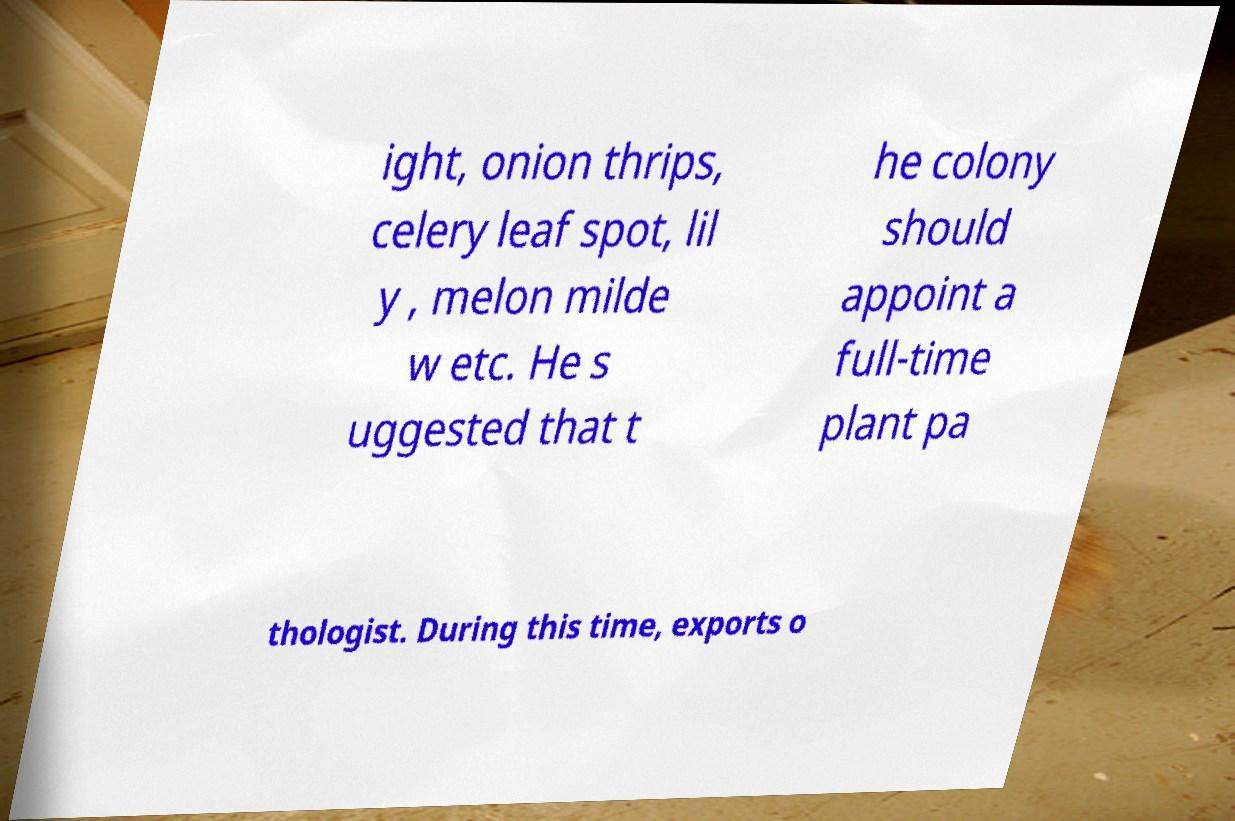Could you extract and type out the text from this image? ight, onion thrips, celery leaf spot, lil y , melon milde w etc. He s uggested that t he colony should appoint a full-time plant pa thologist. During this time, exports o 